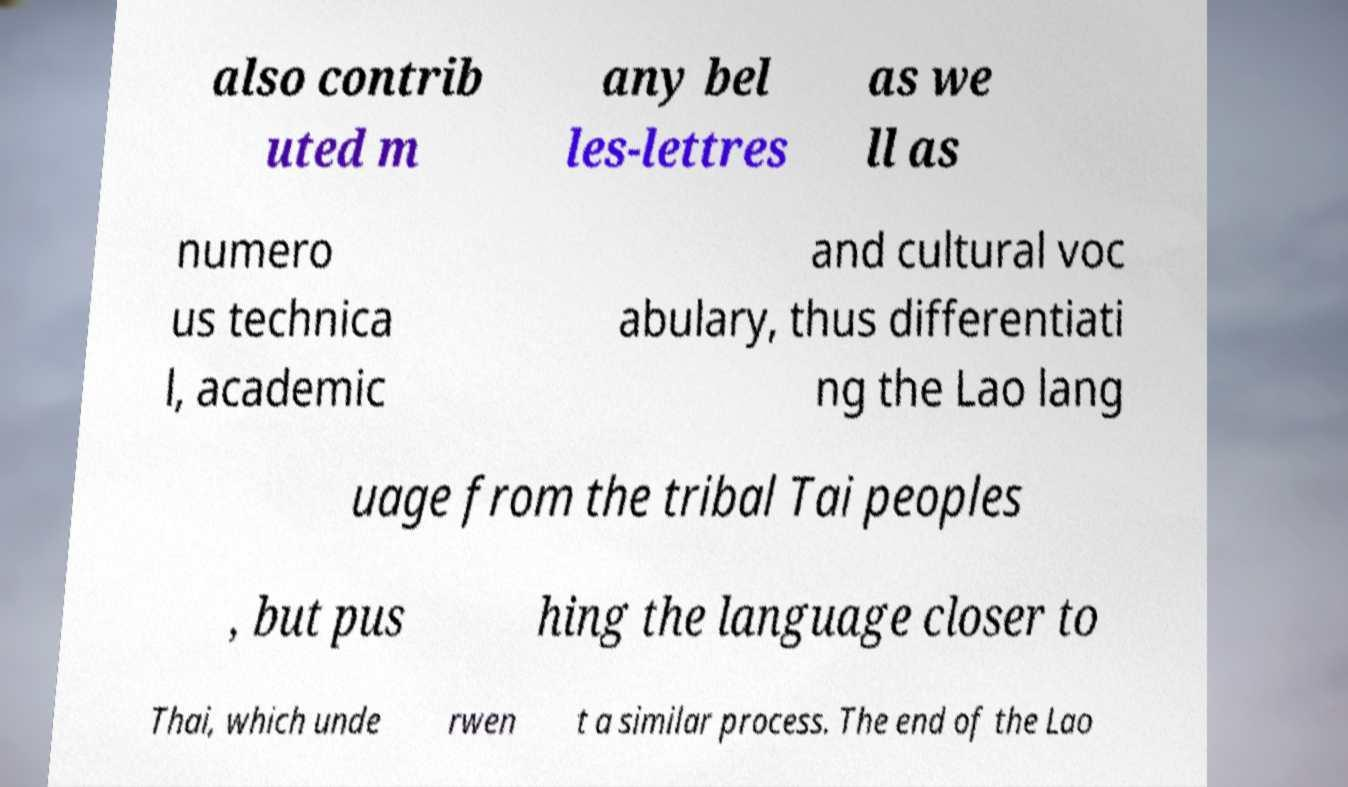What messages or text are displayed in this image? I need them in a readable, typed format. also contrib uted m any bel les-lettres as we ll as numero us technica l, academic and cultural voc abulary, thus differentiati ng the Lao lang uage from the tribal Tai peoples , but pus hing the language closer to Thai, which unde rwen t a similar process. The end of the Lao 